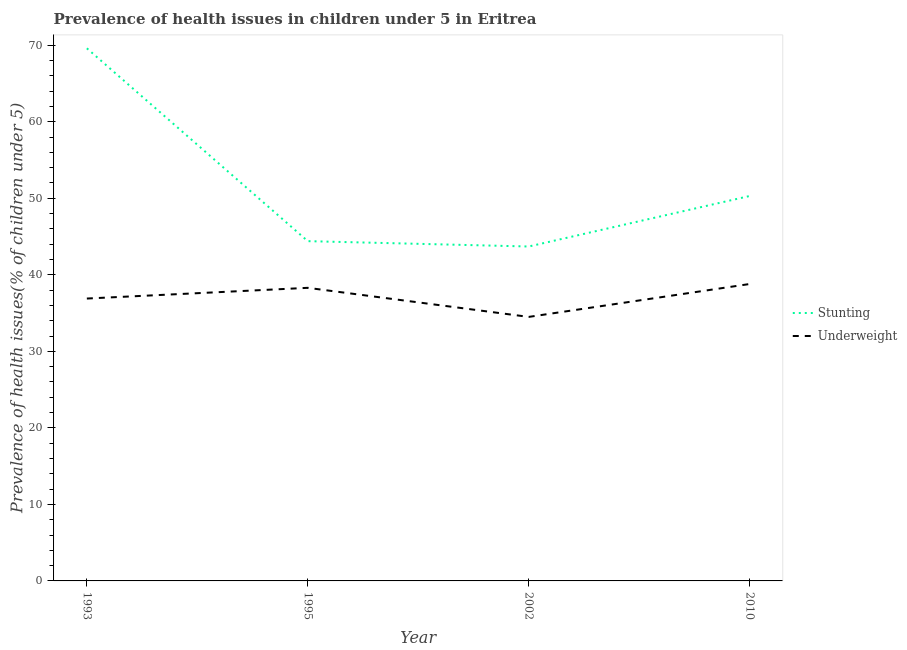Is the number of lines equal to the number of legend labels?
Provide a succinct answer. Yes. What is the percentage of stunted children in 1995?
Your answer should be compact. 44.4. Across all years, what is the maximum percentage of stunted children?
Your answer should be very brief. 69.6. Across all years, what is the minimum percentage of underweight children?
Your response must be concise. 34.5. What is the total percentage of stunted children in the graph?
Your answer should be very brief. 208. What is the difference between the percentage of underweight children in 2002 and that in 2010?
Give a very brief answer. -4.3. What is the difference between the percentage of underweight children in 2010 and the percentage of stunted children in 1993?
Your response must be concise. -30.8. What is the average percentage of underweight children per year?
Make the answer very short. 37.12. In the year 1995, what is the difference between the percentage of underweight children and percentage of stunted children?
Provide a short and direct response. -6.1. What is the ratio of the percentage of stunted children in 1995 to that in 2010?
Provide a short and direct response. 0.88. Is the percentage of stunted children in 1993 less than that in 2002?
Provide a succinct answer. No. Is the difference between the percentage of stunted children in 1995 and 2010 greater than the difference between the percentage of underweight children in 1995 and 2010?
Keep it short and to the point. No. What is the difference between the highest and the lowest percentage of stunted children?
Provide a succinct answer. 25.9. Is the sum of the percentage of stunted children in 1993 and 1995 greater than the maximum percentage of underweight children across all years?
Your answer should be compact. Yes. Is the percentage of underweight children strictly greater than the percentage of stunted children over the years?
Make the answer very short. No. Is the percentage of underweight children strictly less than the percentage of stunted children over the years?
Provide a succinct answer. Yes. Does the graph contain any zero values?
Your answer should be compact. No. How are the legend labels stacked?
Offer a terse response. Vertical. What is the title of the graph?
Provide a succinct answer. Prevalence of health issues in children under 5 in Eritrea. What is the label or title of the Y-axis?
Provide a succinct answer. Prevalence of health issues(% of children under 5). What is the Prevalence of health issues(% of children under 5) in Stunting in 1993?
Give a very brief answer. 69.6. What is the Prevalence of health issues(% of children under 5) in Underweight in 1993?
Provide a succinct answer. 36.9. What is the Prevalence of health issues(% of children under 5) of Stunting in 1995?
Offer a terse response. 44.4. What is the Prevalence of health issues(% of children under 5) of Underweight in 1995?
Your response must be concise. 38.3. What is the Prevalence of health issues(% of children under 5) of Stunting in 2002?
Offer a very short reply. 43.7. What is the Prevalence of health issues(% of children under 5) in Underweight in 2002?
Your answer should be very brief. 34.5. What is the Prevalence of health issues(% of children under 5) of Stunting in 2010?
Make the answer very short. 50.3. What is the Prevalence of health issues(% of children under 5) of Underweight in 2010?
Provide a succinct answer. 38.8. Across all years, what is the maximum Prevalence of health issues(% of children under 5) of Stunting?
Keep it short and to the point. 69.6. Across all years, what is the maximum Prevalence of health issues(% of children under 5) of Underweight?
Give a very brief answer. 38.8. Across all years, what is the minimum Prevalence of health issues(% of children under 5) of Stunting?
Make the answer very short. 43.7. Across all years, what is the minimum Prevalence of health issues(% of children under 5) in Underweight?
Your response must be concise. 34.5. What is the total Prevalence of health issues(% of children under 5) in Stunting in the graph?
Your answer should be very brief. 208. What is the total Prevalence of health issues(% of children under 5) of Underweight in the graph?
Your answer should be very brief. 148.5. What is the difference between the Prevalence of health issues(% of children under 5) of Stunting in 1993 and that in 1995?
Your response must be concise. 25.2. What is the difference between the Prevalence of health issues(% of children under 5) of Underweight in 1993 and that in 1995?
Your answer should be very brief. -1.4. What is the difference between the Prevalence of health issues(% of children under 5) in Stunting in 1993 and that in 2002?
Ensure brevity in your answer.  25.9. What is the difference between the Prevalence of health issues(% of children under 5) in Stunting in 1993 and that in 2010?
Offer a very short reply. 19.3. What is the difference between the Prevalence of health issues(% of children under 5) of Underweight in 1993 and that in 2010?
Your answer should be compact. -1.9. What is the difference between the Prevalence of health issues(% of children under 5) of Underweight in 1995 and that in 2002?
Give a very brief answer. 3.8. What is the difference between the Prevalence of health issues(% of children under 5) in Stunting in 1995 and that in 2010?
Ensure brevity in your answer.  -5.9. What is the difference between the Prevalence of health issues(% of children under 5) of Underweight in 2002 and that in 2010?
Offer a very short reply. -4.3. What is the difference between the Prevalence of health issues(% of children under 5) of Stunting in 1993 and the Prevalence of health issues(% of children under 5) of Underweight in 1995?
Your answer should be very brief. 31.3. What is the difference between the Prevalence of health issues(% of children under 5) of Stunting in 1993 and the Prevalence of health issues(% of children under 5) of Underweight in 2002?
Give a very brief answer. 35.1. What is the difference between the Prevalence of health issues(% of children under 5) of Stunting in 1993 and the Prevalence of health issues(% of children under 5) of Underweight in 2010?
Keep it short and to the point. 30.8. What is the difference between the Prevalence of health issues(% of children under 5) in Stunting in 1995 and the Prevalence of health issues(% of children under 5) in Underweight in 2010?
Your answer should be compact. 5.6. What is the difference between the Prevalence of health issues(% of children under 5) of Stunting in 2002 and the Prevalence of health issues(% of children under 5) of Underweight in 2010?
Your answer should be compact. 4.9. What is the average Prevalence of health issues(% of children under 5) in Stunting per year?
Offer a very short reply. 52. What is the average Prevalence of health issues(% of children under 5) of Underweight per year?
Keep it short and to the point. 37.12. In the year 1993, what is the difference between the Prevalence of health issues(% of children under 5) in Stunting and Prevalence of health issues(% of children under 5) in Underweight?
Provide a succinct answer. 32.7. In the year 1995, what is the difference between the Prevalence of health issues(% of children under 5) in Stunting and Prevalence of health issues(% of children under 5) in Underweight?
Your answer should be compact. 6.1. What is the ratio of the Prevalence of health issues(% of children under 5) in Stunting in 1993 to that in 1995?
Provide a short and direct response. 1.57. What is the ratio of the Prevalence of health issues(% of children under 5) of Underweight in 1993 to that in 1995?
Your response must be concise. 0.96. What is the ratio of the Prevalence of health issues(% of children under 5) of Stunting in 1993 to that in 2002?
Your response must be concise. 1.59. What is the ratio of the Prevalence of health issues(% of children under 5) in Underweight in 1993 to that in 2002?
Keep it short and to the point. 1.07. What is the ratio of the Prevalence of health issues(% of children under 5) in Stunting in 1993 to that in 2010?
Offer a very short reply. 1.38. What is the ratio of the Prevalence of health issues(% of children under 5) in Underweight in 1993 to that in 2010?
Provide a short and direct response. 0.95. What is the ratio of the Prevalence of health issues(% of children under 5) in Stunting in 1995 to that in 2002?
Your answer should be compact. 1.02. What is the ratio of the Prevalence of health issues(% of children under 5) in Underweight in 1995 to that in 2002?
Make the answer very short. 1.11. What is the ratio of the Prevalence of health issues(% of children under 5) of Stunting in 1995 to that in 2010?
Offer a very short reply. 0.88. What is the ratio of the Prevalence of health issues(% of children under 5) of Underweight in 1995 to that in 2010?
Provide a short and direct response. 0.99. What is the ratio of the Prevalence of health issues(% of children under 5) of Stunting in 2002 to that in 2010?
Keep it short and to the point. 0.87. What is the ratio of the Prevalence of health issues(% of children under 5) of Underweight in 2002 to that in 2010?
Make the answer very short. 0.89. What is the difference between the highest and the second highest Prevalence of health issues(% of children under 5) of Stunting?
Provide a short and direct response. 19.3. What is the difference between the highest and the lowest Prevalence of health issues(% of children under 5) of Stunting?
Your answer should be very brief. 25.9. 